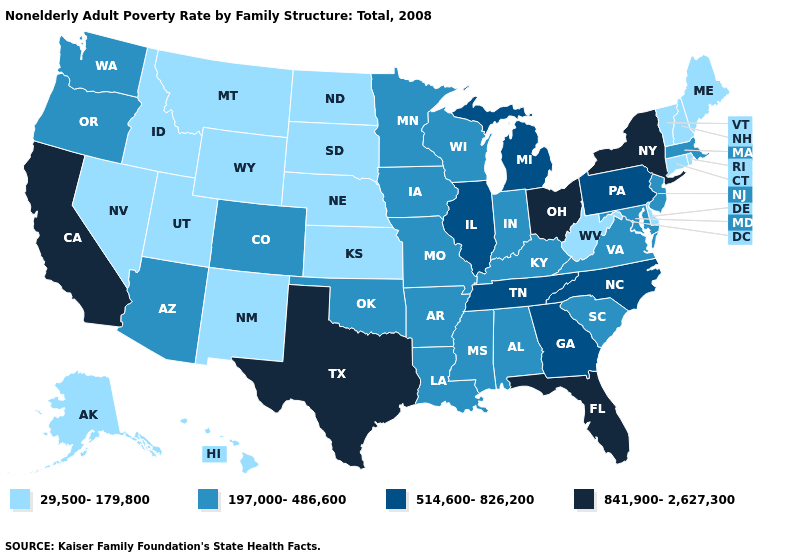Does Montana have the lowest value in the USA?
Short answer required. Yes. How many symbols are there in the legend?
Answer briefly. 4. What is the value of Virginia?
Keep it brief. 197,000-486,600. Does New York have the highest value in the Northeast?
Be succinct. Yes. Among the states that border Nebraska , which have the highest value?
Write a very short answer. Colorado, Iowa, Missouri. Which states have the lowest value in the West?
Quick response, please. Alaska, Hawaii, Idaho, Montana, Nevada, New Mexico, Utah, Wyoming. What is the value of Hawaii?
Keep it brief. 29,500-179,800. Which states have the lowest value in the USA?
Quick response, please. Alaska, Connecticut, Delaware, Hawaii, Idaho, Kansas, Maine, Montana, Nebraska, Nevada, New Hampshire, New Mexico, North Dakota, Rhode Island, South Dakota, Utah, Vermont, West Virginia, Wyoming. Name the states that have a value in the range 29,500-179,800?
Keep it brief. Alaska, Connecticut, Delaware, Hawaii, Idaho, Kansas, Maine, Montana, Nebraska, Nevada, New Hampshire, New Mexico, North Dakota, Rhode Island, South Dakota, Utah, Vermont, West Virginia, Wyoming. Name the states that have a value in the range 841,900-2,627,300?
Concise answer only. California, Florida, New York, Ohio, Texas. Does California have the same value as Hawaii?
Short answer required. No. Name the states that have a value in the range 514,600-826,200?
Short answer required. Georgia, Illinois, Michigan, North Carolina, Pennsylvania, Tennessee. Name the states that have a value in the range 197,000-486,600?
Be succinct. Alabama, Arizona, Arkansas, Colorado, Indiana, Iowa, Kentucky, Louisiana, Maryland, Massachusetts, Minnesota, Mississippi, Missouri, New Jersey, Oklahoma, Oregon, South Carolina, Virginia, Washington, Wisconsin. How many symbols are there in the legend?
Be succinct. 4. What is the lowest value in the West?
Answer briefly. 29,500-179,800. 